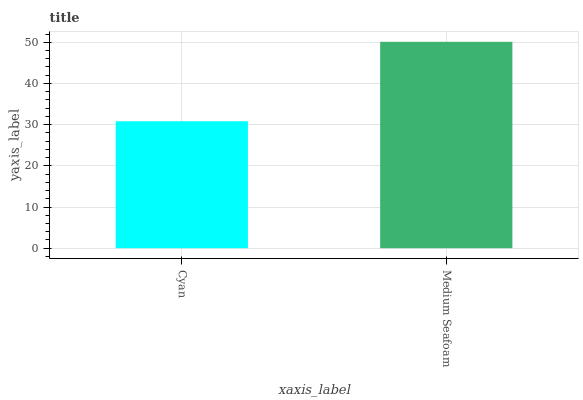Is Cyan the minimum?
Answer yes or no. Yes. Is Medium Seafoam the maximum?
Answer yes or no. Yes. Is Medium Seafoam the minimum?
Answer yes or no. No. Is Medium Seafoam greater than Cyan?
Answer yes or no. Yes. Is Cyan less than Medium Seafoam?
Answer yes or no. Yes. Is Cyan greater than Medium Seafoam?
Answer yes or no. No. Is Medium Seafoam less than Cyan?
Answer yes or no. No. Is Medium Seafoam the high median?
Answer yes or no. Yes. Is Cyan the low median?
Answer yes or no. Yes. Is Cyan the high median?
Answer yes or no. No. Is Medium Seafoam the low median?
Answer yes or no. No. 